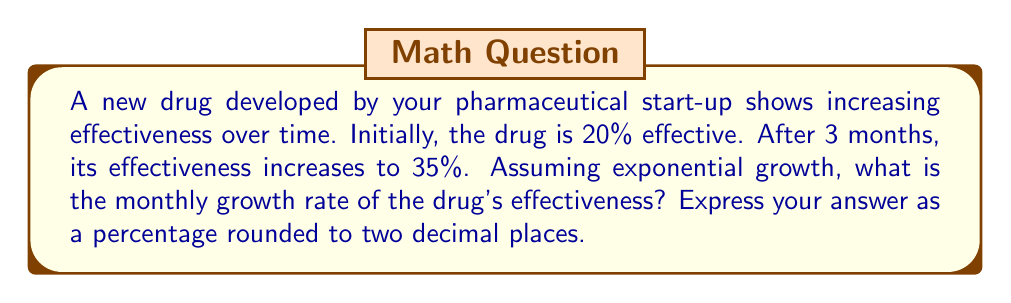Teach me how to tackle this problem. Let's approach this step-by-step using the exponential growth formula:

1) The exponential growth formula is:
   $A = P(1 + r)^t$
   Where:
   $A$ is the final amount
   $P$ is the initial amount
   $r$ is the growth rate (in decimal form)
   $t$ is the time period

2) We know:
   $P = 20\%$ (initial effectiveness)
   $A = 35\%$ (effectiveness after 3 months)
   $t = 3$ (3 months)

3) Let's plug these into our formula:
   $35 = 20(1 + r)^3$

4) Divide both sides by 20:
   $\frac{35}{20} = (1 + r)^3$

5) Take the cube root of both sides:
   $\sqrt[3]{\frac{35}{20}} = 1 + r$

6) Subtract 1 from both sides:
   $\sqrt[3]{\frac{35}{20}} - 1 = r$

7) Calculate:
   $r = \sqrt[3]{1.75} - 1 = 1.2009 - 1 = 0.2009$

8) Convert to a percentage:
   $0.2009 * 100 = 20.09\%$

9) Round to two decimal places:
   $20.09\%$ rounds to $20.09\%$
Answer: 20.09% 